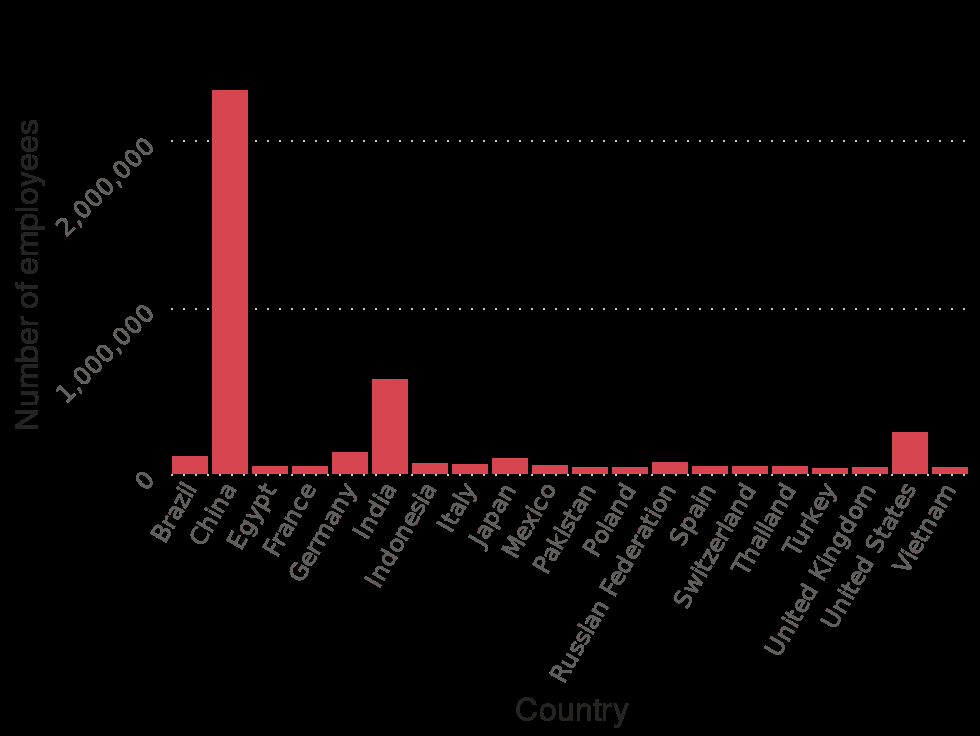<image>
please summary the statistics and relations of the chart The top country is China with over 2,000,000 employees. Most of the other countries such as Spain, Poland and Mexico have less than 500,000 employees. 